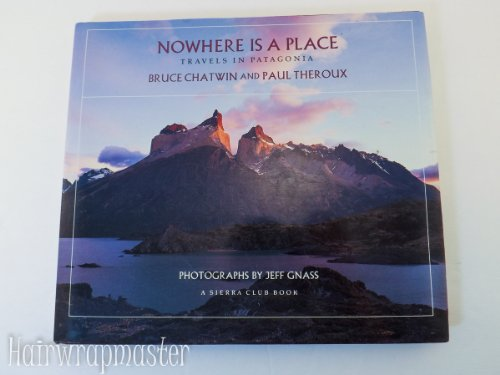What is the title of this book? The title of the book is 'Nowhere Is a Place: Travels in Patagonia, a Sierra Club Book (Hardback)', which hints at a journey through the intriguing and remote landscapes of Patagonia. 